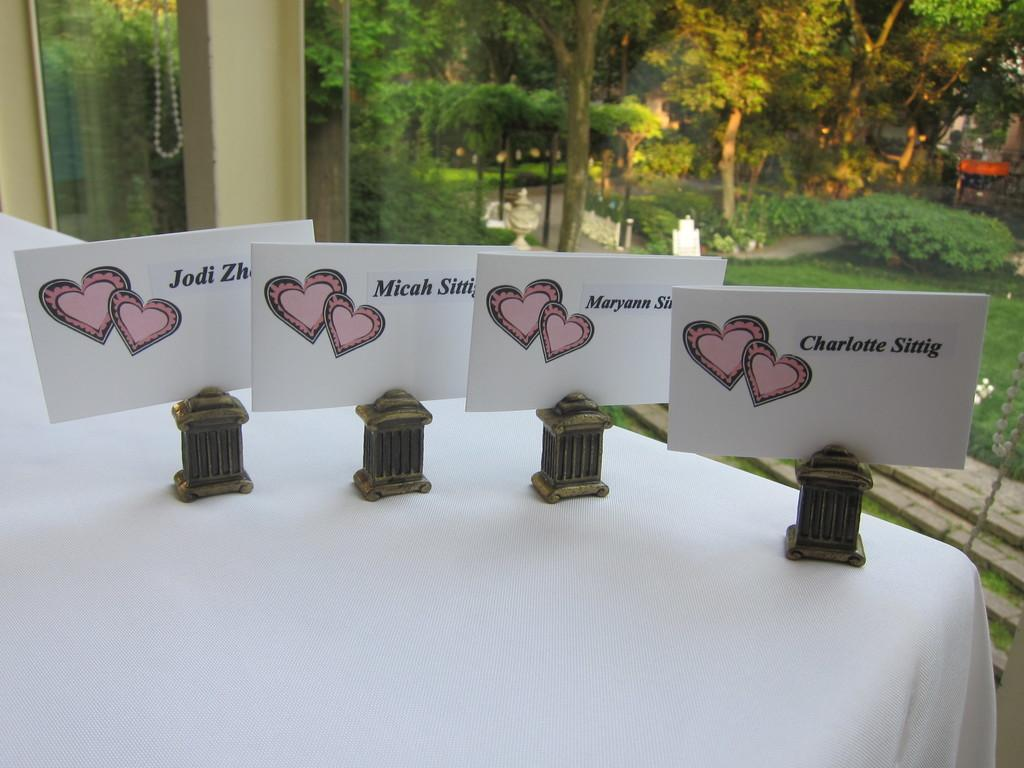What type of furniture is present in the image? There is a table in the image. What can be seen on or near the table? There are name boards on or near the table. What type of wall is visible in the image? There is a glass wall in the image. What can be seen through the glass wall? The glass wall provides a view of trees. What type of instrument is being played by the band in the image? There is no band or instrument present in the image. 